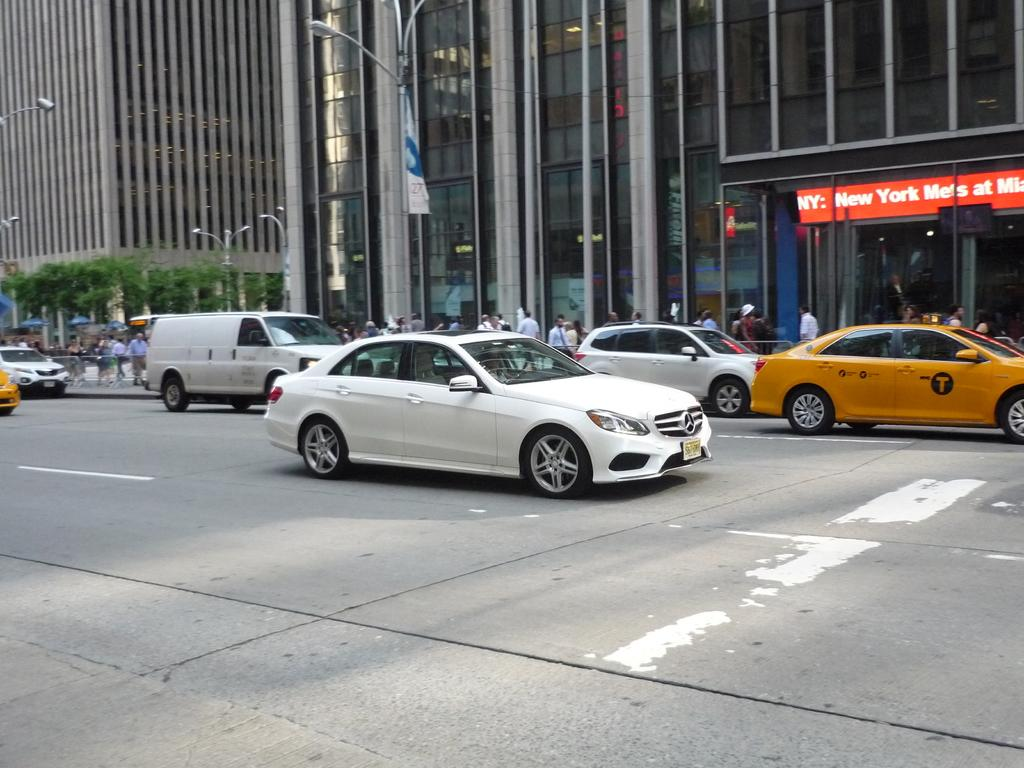<image>
Describe the image concisely. A red digital sign advertises that the New York Mets will be playing. 